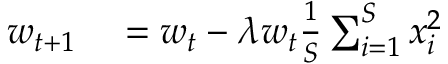<formula> <loc_0><loc_0><loc_500><loc_500>\begin{array} { r l } { w _ { t + 1 } } & = w _ { t } - \lambda w _ { t } \frac { 1 } { S } \sum _ { i = 1 } ^ { S } x _ { i } ^ { 2 } } \end{array}</formula> 